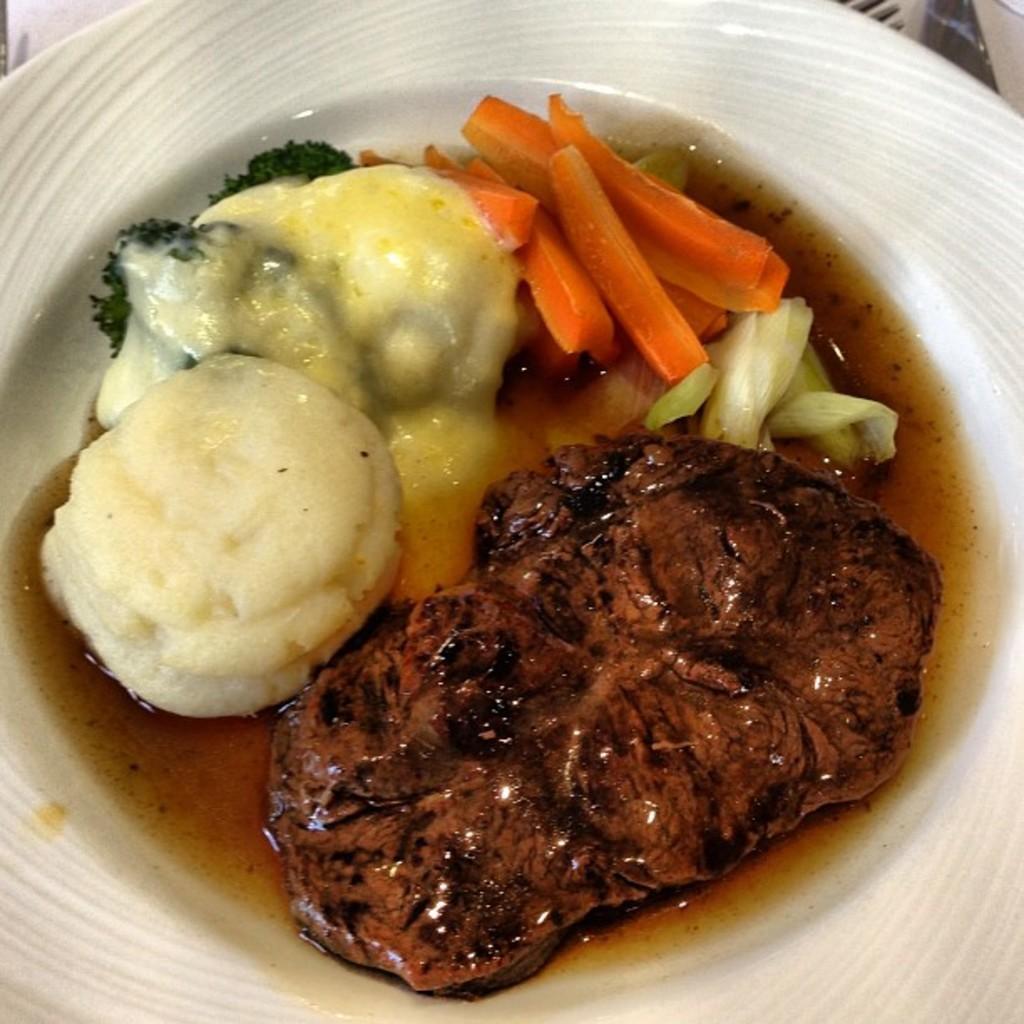Can you describe this image briefly? In this image I can see a food in the white color plate. Food is in brown,white,cream,green and orange color. 